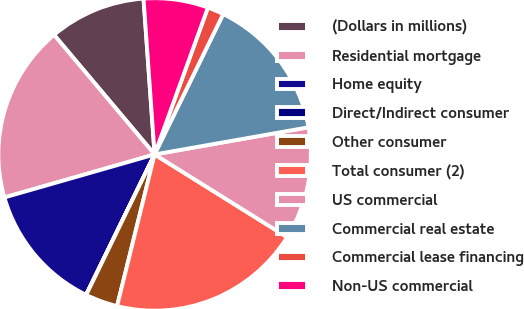Convert chart to OTSL. <chart><loc_0><loc_0><loc_500><loc_500><pie_chart><fcel>(Dollars in millions)<fcel>Residential mortgage<fcel>Home equity<fcel>Direct/Indirect consumer<fcel>Other consumer<fcel>Total consumer (2)<fcel>US commercial<fcel>Commercial real estate<fcel>Commercial lease financing<fcel>Non-US commercial<nl><fcel>10.0%<fcel>18.31%<fcel>13.33%<fcel>0.02%<fcel>3.35%<fcel>19.98%<fcel>11.66%<fcel>14.99%<fcel>1.69%<fcel>6.67%<nl></chart> 